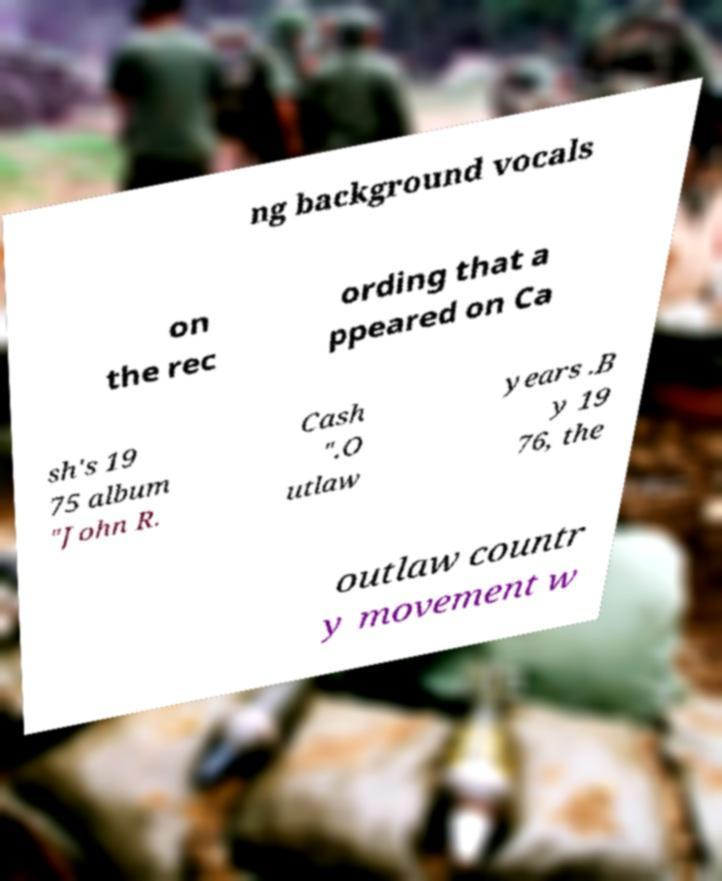Please read and relay the text visible in this image. What does it say? ng background vocals on the rec ording that a ppeared on Ca sh's 19 75 album "John R. Cash ".O utlaw years .B y 19 76, the outlaw countr y movement w 